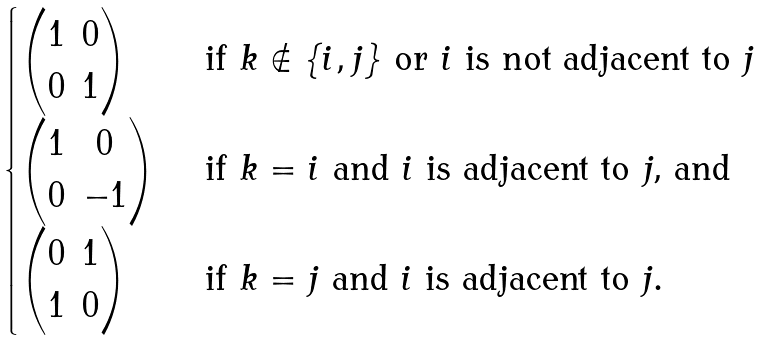<formula> <loc_0><loc_0><loc_500><loc_500>\begin{cases} \begin{pmatrix} 1 & 0 \\ 0 & 1 \end{pmatrix} & \text { if $k\notin \{i,j\}$ or $i$ is not adjacent to $j$} \\ \begin{pmatrix} 1 & 0 \\ 0 & - 1 \end{pmatrix} & \text { if $k=i$ and $i$ is adjacent to $j$, and} \\ \begin{pmatrix} 0 & 1 \\ 1 & 0 \end{pmatrix} & \text { if $k=j$ and $i$ is adjacent to $j$.} \end{cases}</formula> 